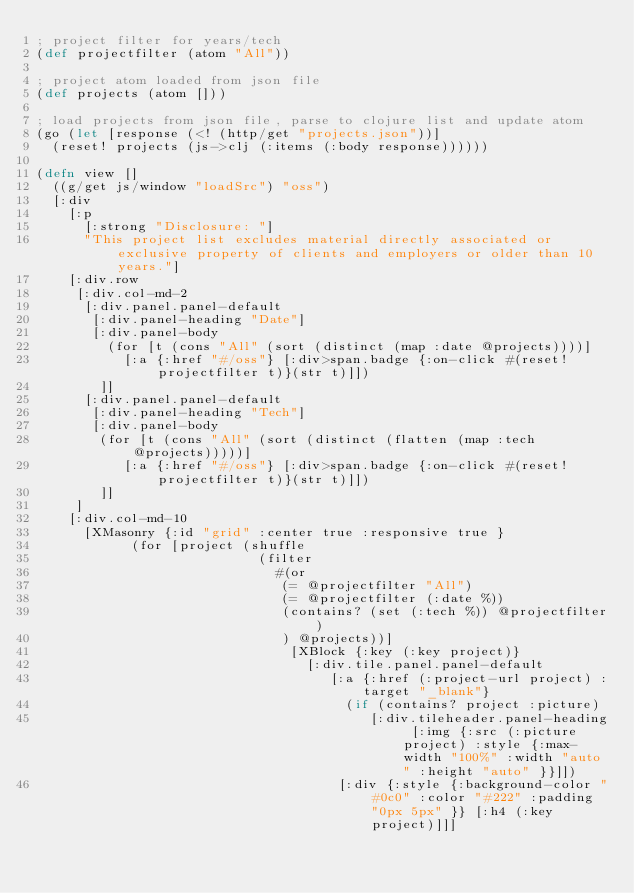Convert code to text. <code><loc_0><loc_0><loc_500><loc_500><_Clojure_>; project filter for years/tech
(def projectfilter (atom "All"))

; project atom loaded from json file
(def projects (atom []))

; load projects from json file, parse to clojure list and update atom
(go (let [response (<! (http/get "projects.json"))]
  (reset! projects (js->clj (:items (:body response))))))

(defn view []
  ((g/get js/window "loadSrc") "oss")
  [:div 
    [:p 
      [:strong "Disclosure: "]
      "This project list excludes material directly associated or exclusive property of clients and employers or older than 10 years."]
    [:div.row
     [:div.col-md-2
      [:div.panel.panel-default
       [:div.panel-heading "Date"]
       [:div.panel-body
         (for [t (cons "All" (sort (distinct (map :date @projects))))]
           [:a {:href "#/oss"} [:div>span.badge {:on-click #(reset! projectfilter t)}(str t)]])
        ]]
      [:div.panel.panel-default
       [:div.panel-heading "Tech"]
       [:div.panel-body
        (for [t (cons "All" (sort (distinct (flatten (map :tech @projects)))))]
           [:a {:href "#/oss"} [:div>span.badge {:on-click #(reset! projectfilter t)}(str t)]])
        ]]
     ]
    [:div.col-md-10
      [XMasonry {:id "grid" :center true :responsive true }
            (for [project (shuffle
                            (filter
                              #(or
                               (= @projectfilter "All")
                               (= @projectfilter (:date %))
                               (contains? (set (:tech %)) @projectfilter)
                               ) @projects))]
                                [XBlock {:key (:key project)}
                                  [:div.tile.panel.panel-default 
                                     [:a {:href (:project-url project) :target "_blank"}
                                       (if (contains? project :picture)
                                          [:div.tileheader.panel-heading [:img {:src (:picture project) :style {:max-width "100%" :width "auto" :height "auto" }}]])
                                      [:div {:style {:background-color "#0c0" :color "#222" :padding "0px 5px" }} [:h4 (:key project)]]]</code> 